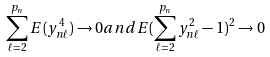Convert formula to latex. <formula><loc_0><loc_0><loc_500><loc_500>\sum ^ { p _ { n } } _ { \ell = 2 } E ( y _ { n \ell } ^ { 4 } ) \to 0 a n d E ( \sum _ { \ell = 2 } ^ { p _ { n } } y _ { n \ell } ^ { 2 } - 1 ) ^ { 2 } \to 0</formula> 